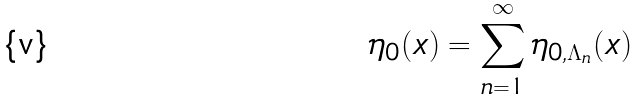<formula> <loc_0><loc_0><loc_500><loc_500>\eta _ { 0 } ( x ) = \sum _ { n = 1 } ^ { \infty } \eta _ { 0 , \Lambda _ { n } } ( x )</formula> 